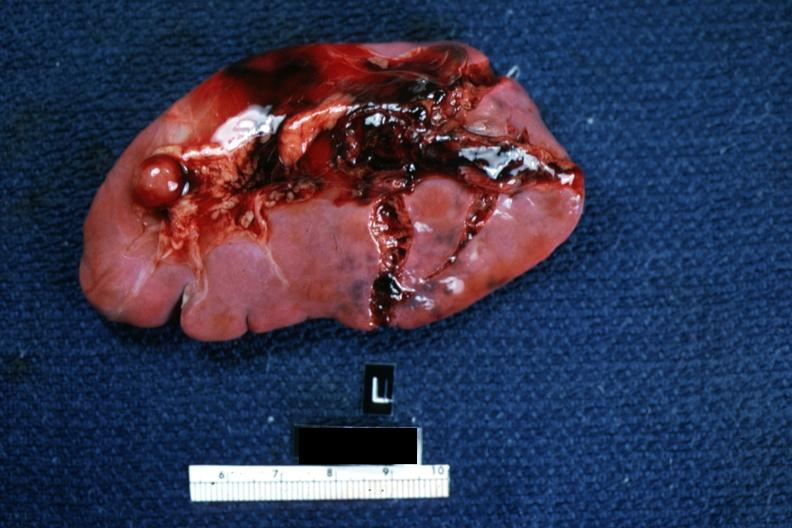s traumatic rupture present?
Answer the question using a single word or phrase. Yes 